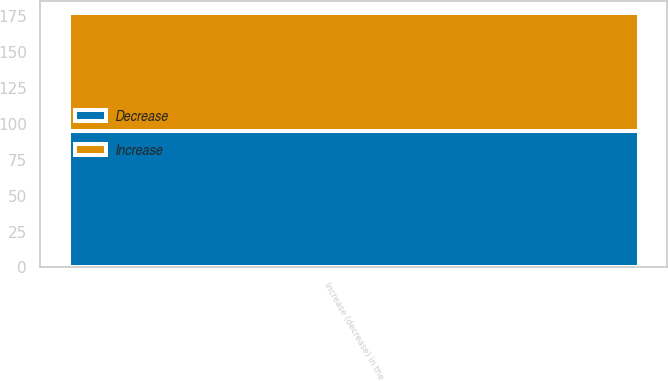Convert chart. <chart><loc_0><loc_0><loc_500><loc_500><stacked_bar_chart><ecel><fcel>Increase (decrease) in the<nl><fcel>Decrease<fcel>95<nl><fcel>Increase<fcel>82<nl></chart> 